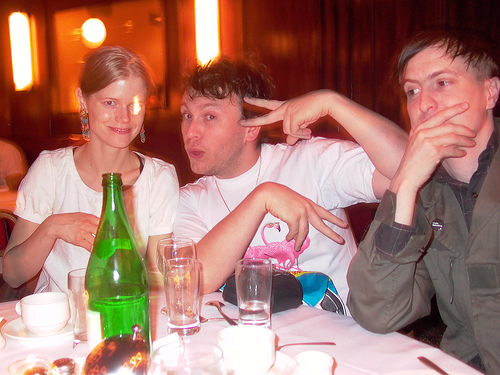<image>
Is there a cup behind the bottle? Yes. From this viewpoint, the cup is positioned behind the bottle, with the bottle partially or fully occluding the cup. Is the bottle behind the table? No. The bottle is not behind the table. From this viewpoint, the bottle appears to be positioned elsewhere in the scene. 